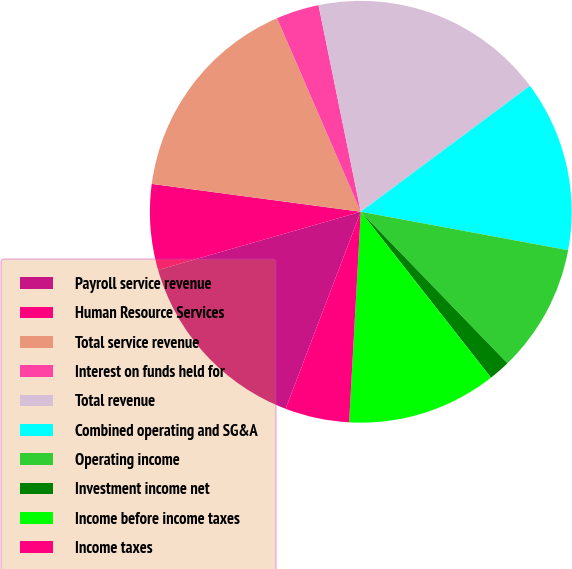Convert chart to OTSL. <chart><loc_0><loc_0><loc_500><loc_500><pie_chart><fcel>Payroll service revenue<fcel>Human Resource Services<fcel>Total service revenue<fcel>Interest on funds held for<fcel>Total revenue<fcel>Combined operating and SG&A<fcel>Operating income<fcel>Investment income net<fcel>Income before income taxes<fcel>Income taxes<nl><fcel>14.75%<fcel>6.56%<fcel>16.39%<fcel>3.29%<fcel>18.02%<fcel>13.11%<fcel>9.84%<fcel>1.65%<fcel>11.47%<fcel>4.92%<nl></chart> 